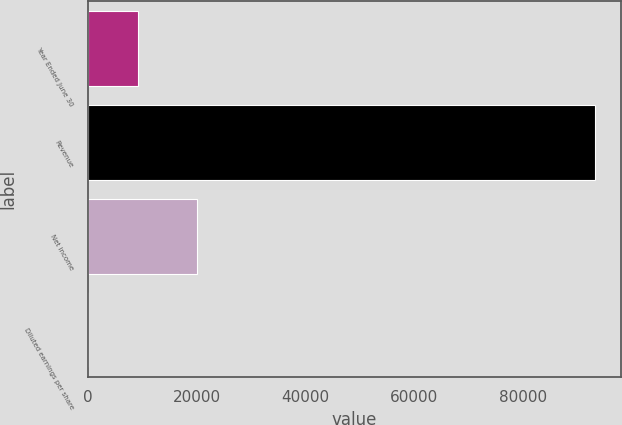Convert chart to OTSL. <chart><loc_0><loc_0><loc_500><loc_500><bar_chart><fcel>Year Ended June 30<fcel>Revenue<fcel>Net income<fcel>Diluted earnings per share<nl><fcel>9326.44<fcel>93243<fcel>20153<fcel>2.38<nl></chart> 